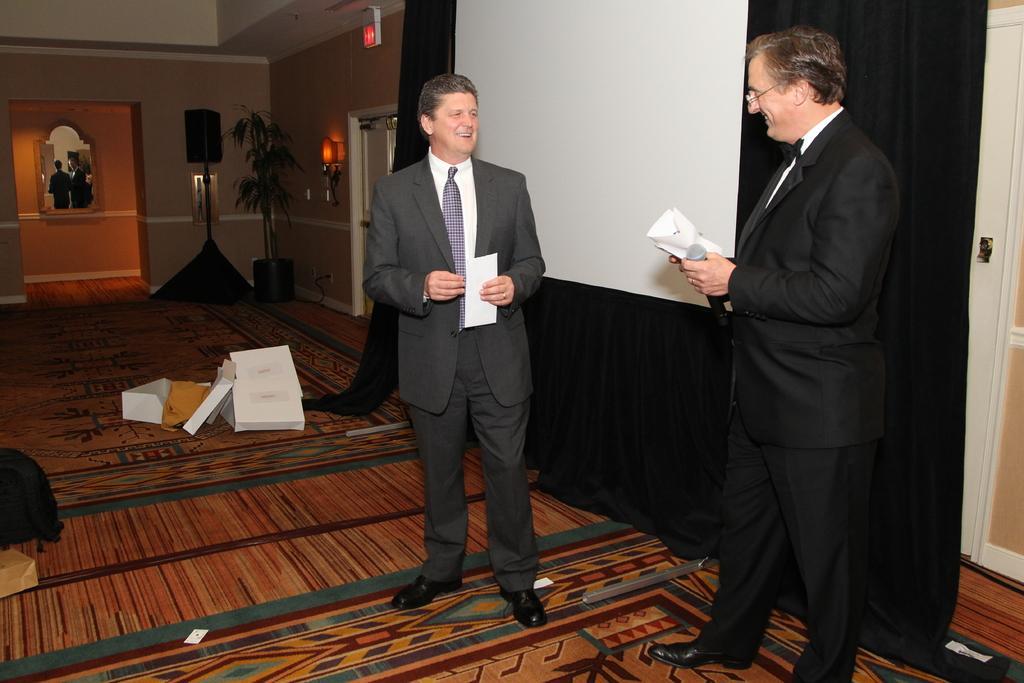In one or two sentences, can you explain what this image depicts? This is an inside view. On the right side two men are wearing suits, holding some papers in the hands, standing and smiling by looking at each other. At the back of these people there is a wall also I can see black color curtains. In the background there is a metal stand and a house plant are placed on the floor and also I can see few boxes and a bag. On the left side there is a mirror attached to the wall. 